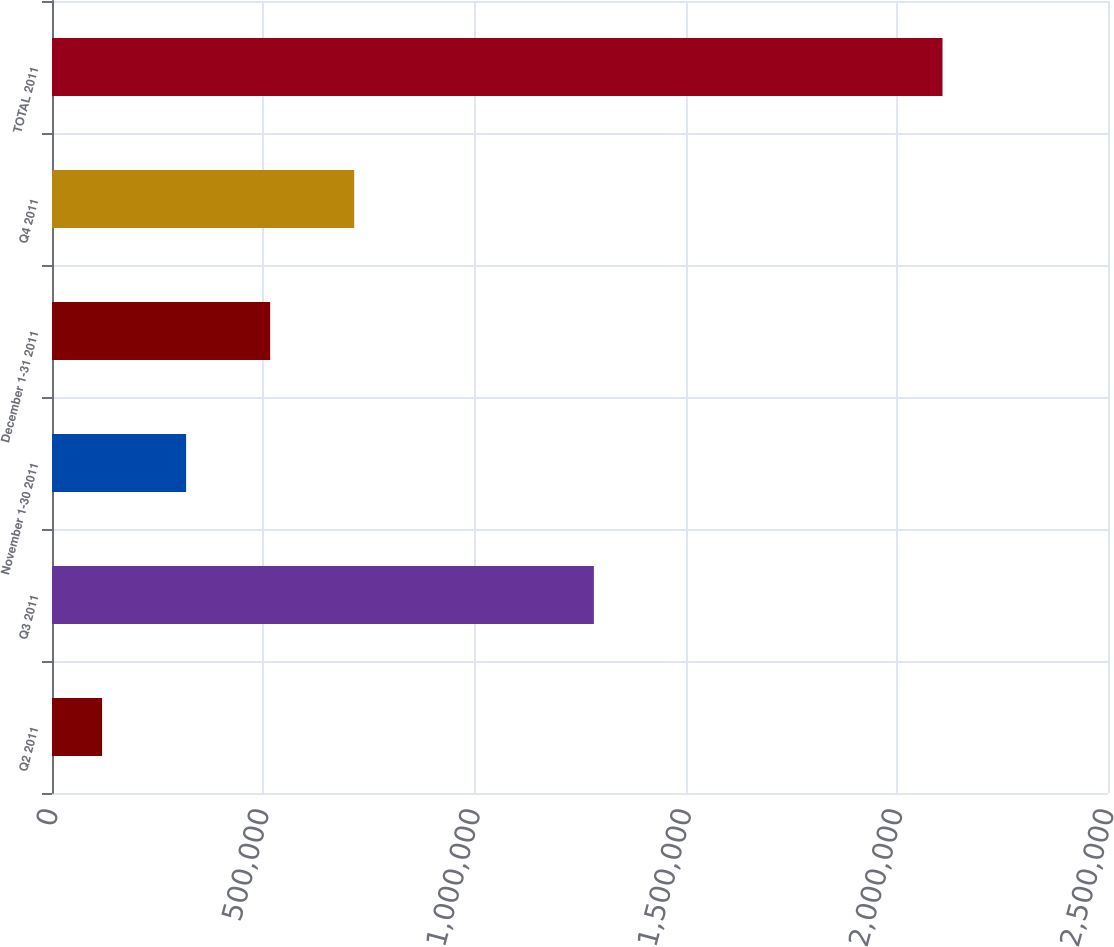Convert chart to OTSL. <chart><loc_0><loc_0><loc_500><loc_500><bar_chart><fcel>Q2 2011<fcel>Q3 2011<fcel>November 1-30 2011<fcel>December 1-31 2011<fcel>Q4 2011<fcel>TOTAL 2011<nl><fcel>118578<fcel>1.28281e+06<fcel>317536<fcel>516494<fcel>715452<fcel>2.10816e+06<nl></chart> 